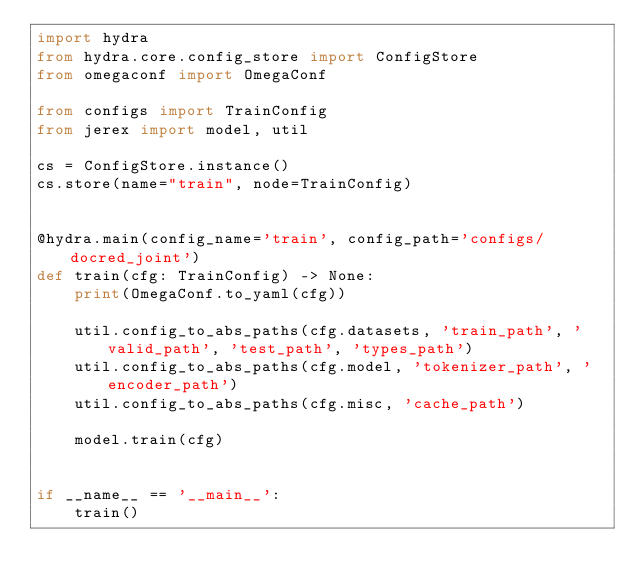Convert code to text. <code><loc_0><loc_0><loc_500><loc_500><_Python_>import hydra
from hydra.core.config_store import ConfigStore
from omegaconf import OmegaConf

from configs import TrainConfig
from jerex import model, util

cs = ConfigStore.instance()
cs.store(name="train", node=TrainConfig)


@hydra.main(config_name='train', config_path='configs/docred_joint')
def train(cfg: TrainConfig) -> None:
    print(OmegaConf.to_yaml(cfg))

    util.config_to_abs_paths(cfg.datasets, 'train_path', 'valid_path', 'test_path', 'types_path')
    util.config_to_abs_paths(cfg.model, 'tokenizer_path', 'encoder_path')
    util.config_to_abs_paths(cfg.misc, 'cache_path')

    model.train(cfg)


if __name__ == '__main__':
    train()
</code> 